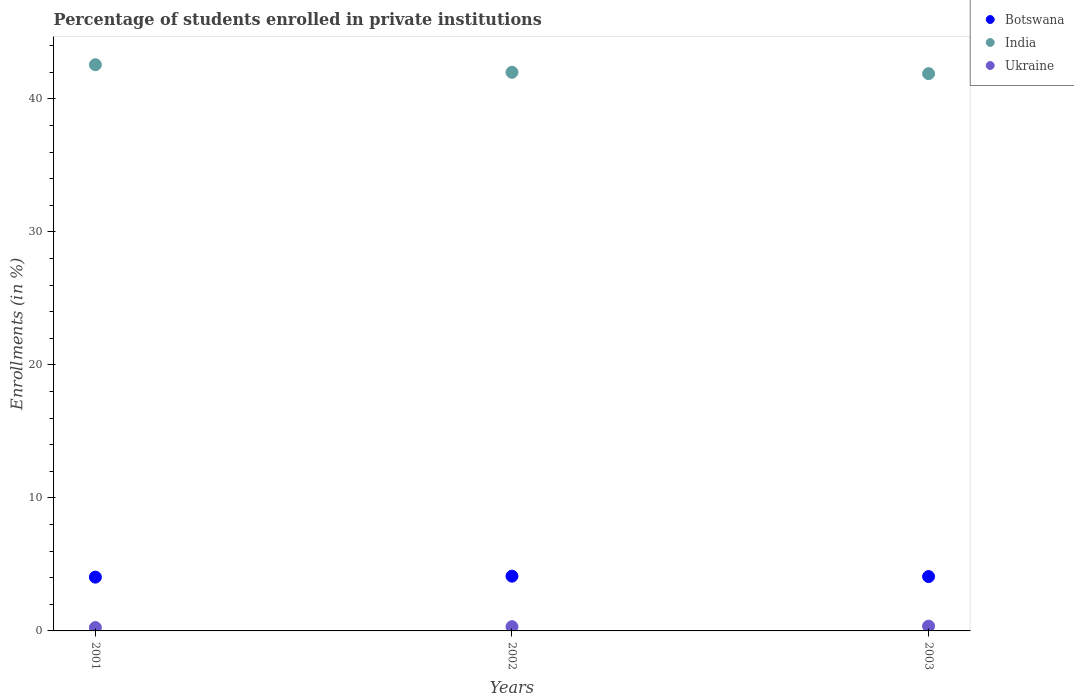Is the number of dotlines equal to the number of legend labels?
Offer a very short reply. Yes. What is the percentage of trained teachers in Botswana in 2003?
Give a very brief answer. 4.09. Across all years, what is the maximum percentage of trained teachers in Ukraine?
Offer a very short reply. 0.36. Across all years, what is the minimum percentage of trained teachers in Botswana?
Make the answer very short. 4.04. In which year was the percentage of trained teachers in Botswana maximum?
Ensure brevity in your answer.  2002. What is the total percentage of trained teachers in Botswana in the graph?
Keep it short and to the point. 12.25. What is the difference between the percentage of trained teachers in Ukraine in 2001 and that in 2002?
Ensure brevity in your answer.  -0.07. What is the difference between the percentage of trained teachers in India in 2002 and the percentage of trained teachers in Ukraine in 2001?
Ensure brevity in your answer.  41.74. What is the average percentage of trained teachers in Ukraine per year?
Provide a short and direct response. 0.31. In the year 2002, what is the difference between the percentage of trained teachers in Ukraine and percentage of trained teachers in Botswana?
Keep it short and to the point. -3.8. In how many years, is the percentage of trained teachers in Ukraine greater than 26 %?
Keep it short and to the point. 0. What is the ratio of the percentage of trained teachers in Ukraine in 2001 to that in 2003?
Provide a short and direct response. 0.7. Is the difference between the percentage of trained teachers in Ukraine in 2002 and 2003 greater than the difference between the percentage of trained teachers in Botswana in 2002 and 2003?
Make the answer very short. No. What is the difference between the highest and the second highest percentage of trained teachers in Botswana?
Offer a very short reply. 0.03. What is the difference between the highest and the lowest percentage of trained teachers in Botswana?
Offer a terse response. 0.07. In how many years, is the percentage of trained teachers in Ukraine greater than the average percentage of trained teachers in Ukraine taken over all years?
Your answer should be compact. 2. Is it the case that in every year, the sum of the percentage of trained teachers in India and percentage of trained teachers in Ukraine  is greater than the percentage of trained teachers in Botswana?
Give a very brief answer. Yes. Does the percentage of trained teachers in India monotonically increase over the years?
Your answer should be very brief. No. Is the percentage of trained teachers in Botswana strictly less than the percentage of trained teachers in Ukraine over the years?
Ensure brevity in your answer.  No. What is the difference between two consecutive major ticks on the Y-axis?
Provide a short and direct response. 10. Does the graph contain any zero values?
Keep it short and to the point. No. Does the graph contain grids?
Offer a very short reply. No. Where does the legend appear in the graph?
Offer a very short reply. Top right. How are the legend labels stacked?
Give a very brief answer. Vertical. What is the title of the graph?
Make the answer very short. Percentage of students enrolled in private institutions. Does "Tunisia" appear as one of the legend labels in the graph?
Offer a very short reply. No. What is the label or title of the Y-axis?
Provide a short and direct response. Enrollments (in %). What is the Enrollments (in %) of Botswana in 2001?
Provide a succinct answer. 4.04. What is the Enrollments (in %) of India in 2001?
Provide a short and direct response. 42.56. What is the Enrollments (in %) in Ukraine in 2001?
Ensure brevity in your answer.  0.25. What is the Enrollments (in %) in Botswana in 2002?
Ensure brevity in your answer.  4.12. What is the Enrollments (in %) in India in 2002?
Keep it short and to the point. 41.99. What is the Enrollments (in %) of Ukraine in 2002?
Provide a succinct answer. 0.32. What is the Enrollments (in %) of Botswana in 2003?
Offer a terse response. 4.09. What is the Enrollments (in %) in India in 2003?
Your response must be concise. 41.89. What is the Enrollments (in %) of Ukraine in 2003?
Make the answer very short. 0.36. Across all years, what is the maximum Enrollments (in %) in Botswana?
Provide a short and direct response. 4.12. Across all years, what is the maximum Enrollments (in %) of India?
Give a very brief answer. 42.56. Across all years, what is the maximum Enrollments (in %) of Ukraine?
Give a very brief answer. 0.36. Across all years, what is the minimum Enrollments (in %) of Botswana?
Your answer should be very brief. 4.04. Across all years, what is the minimum Enrollments (in %) in India?
Give a very brief answer. 41.89. Across all years, what is the minimum Enrollments (in %) in Ukraine?
Your response must be concise. 0.25. What is the total Enrollments (in %) of Botswana in the graph?
Provide a short and direct response. 12.25. What is the total Enrollments (in %) in India in the graph?
Provide a succinct answer. 126.45. What is the total Enrollments (in %) in Ukraine in the graph?
Ensure brevity in your answer.  0.93. What is the difference between the Enrollments (in %) in Botswana in 2001 and that in 2002?
Offer a very short reply. -0.07. What is the difference between the Enrollments (in %) in India in 2001 and that in 2002?
Your answer should be very brief. 0.57. What is the difference between the Enrollments (in %) of Ukraine in 2001 and that in 2002?
Your answer should be very brief. -0.07. What is the difference between the Enrollments (in %) in Botswana in 2001 and that in 2003?
Give a very brief answer. -0.04. What is the difference between the Enrollments (in %) of India in 2001 and that in 2003?
Ensure brevity in your answer.  0.67. What is the difference between the Enrollments (in %) in Ukraine in 2001 and that in 2003?
Give a very brief answer. -0.11. What is the difference between the Enrollments (in %) of Botswana in 2002 and that in 2003?
Provide a succinct answer. 0.03. What is the difference between the Enrollments (in %) of India in 2002 and that in 2003?
Your response must be concise. 0.1. What is the difference between the Enrollments (in %) in Ukraine in 2002 and that in 2003?
Your answer should be very brief. -0.04. What is the difference between the Enrollments (in %) in Botswana in 2001 and the Enrollments (in %) in India in 2002?
Your answer should be very brief. -37.95. What is the difference between the Enrollments (in %) of Botswana in 2001 and the Enrollments (in %) of Ukraine in 2002?
Offer a very short reply. 3.73. What is the difference between the Enrollments (in %) in India in 2001 and the Enrollments (in %) in Ukraine in 2002?
Your answer should be very brief. 42.25. What is the difference between the Enrollments (in %) in Botswana in 2001 and the Enrollments (in %) in India in 2003?
Keep it short and to the point. -37.85. What is the difference between the Enrollments (in %) in Botswana in 2001 and the Enrollments (in %) in Ukraine in 2003?
Offer a terse response. 3.69. What is the difference between the Enrollments (in %) in India in 2001 and the Enrollments (in %) in Ukraine in 2003?
Offer a terse response. 42.2. What is the difference between the Enrollments (in %) of Botswana in 2002 and the Enrollments (in %) of India in 2003?
Your answer should be compact. -37.78. What is the difference between the Enrollments (in %) in Botswana in 2002 and the Enrollments (in %) in Ukraine in 2003?
Your response must be concise. 3.76. What is the difference between the Enrollments (in %) of India in 2002 and the Enrollments (in %) of Ukraine in 2003?
Make the answer very short. 41.63. What is the average Enrollments (in %) of Botswana per year?
Provide a succinct answer. 4.08. What is the average Enrollments (in %) of India per year?
Keep it short and to the point. 42.15. What is the average Enrollments (in %) of Ukraine per year?
Your answer should be compact. 0.31. In the year 2001, what is the difference between the Enrollments (in %) of Botswana and Enrollments (in %) of India?
Make the answer very short. -38.52. In the year 2001, what is the difference between the Enrollments (in %) of Botswana and Enrollments (in %) of Ukraine?
Ensure brevity in your answer.  3.79. In the year 2001, what is the difference between the Enrollments (in %) in India and Enrollments (in %) in Ukraine?
Make the answer very short. 42.31. In the year 2002, what is the difference between the Enrollments (in %) of Botswana and Enrollments (in %) of India?
Your answer should be very brief. -37.88. In the year 2002, what is the difference between the Enrollments (in %) in Botswana and Enrollments (in %) in Ukraine?
Your response must be concise. 3.8. In the year 2002, what is the difference between the Enrollments (in %) of India and Enrollments (in %) of Ukraine?
Your response must be concise. 41.68. In the year 2003, what is the difference between the Enrollments (in %) of Botswana and Enrollments (in %) of India?
Offer a very short reply. -37.81. In the year 2003, what is the difference between the Enrollments (in %) of Botswana and Enrollments (in %) of Ukraine?
Ensure brevity in your answer.  3.73. In the year 2003, what is the difference between the Enrollments (in %) of India and Enrollments (in %) of Ukraine?
Provide a succinct answer. 41.53. What is the ratio of the Enrollments (in %) of Botswana in 2001 to that in 2002?
Give a very brief answer. 0.98. What is the ratio of the Enrollments (in %) in India in 2001 to that in 2002?
Make the answer very short. 1.01. What is the ratio of the Enrollments (in %) in Ukraine in 2001 to that in 2002?
Offer a very short reply. 0.79. What is the ratio of the Enrollments (in %) in Ukraine in 2001 to that in 2003?
Your answer should be very brief. 0.7. What is the ratio of the Enrollments (in %) of India in 2002 to that in 2003?
Your response must be concise. 1. What is the ratio of the Enrollments (in %) of Ukraine in 2002 to that in 2003?
Offer a very short reply. 0.88. What is the difference between the highest and the second highest Enrollments (in %) of Botswana?
Keep it short and to the point. 0.03. What is the difference between the highest and the second highest Enrollments (in %) of India?
Offer a terse response. 0.57. What is the difference between the highest and the second highest Enrollments (in %) of Ukraine?
Ensure brevity in your answer.  0.04. What is the difference between the highest and the lowest Enrollments (in %) in Botswana?
Make the answer very short. 0.07. What is the difference between the highest and the lowest Enrollments (in %) in India?
Give a very brief answer. 0.67. What is the difference between the highest and the lowest Enrollments (in %) of Ukraine?
Provide a succinct answer. 0.11. 